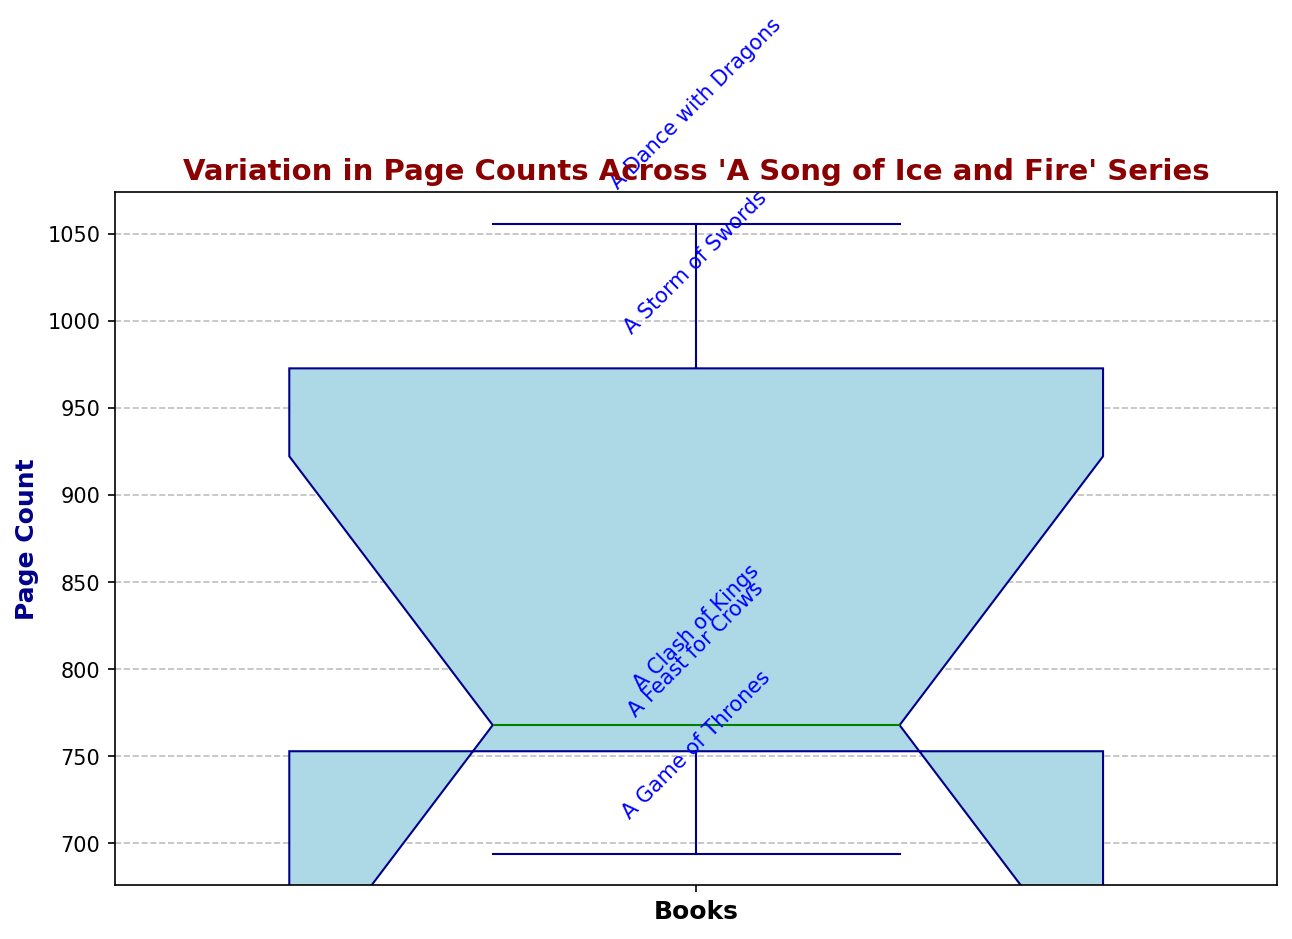Which book has the highest page count? The box plot shows individual page counts for each book in the 'A Song of Ice and Fire' series. By looking at the highest points for each book, "A Dance with Dragons" has the highest page count, indicated at the top of the plot.
Answer: A Dance with Dragons What is the median page count of the series? The median is represented by the green line in the box plot. The median page count for the series is the green line inside the box. In this case, it is around the median page count of "A Storm of Swords," which we approximate to be around 768 pages.
Answer: 768 How many books have a page count higher than 800? The plot shows individual page counts for each book. By looking at the heights above 800, we can count the books accordingly. "A Storm of Swords" and "A Dance with Dragons" both have counts above 800.
Answer: 2 What is the range of the page counts? The range is found by subtracting the smallest page count from the largest page count. The smallest page count is "A Game of Thrones" at 694 pages, and the largest is "A Dance with Dragons" at 1056 pages. The range is thus 1056 - 694.
Answer: 362 Which book has the smallest page count, and how much is it? On the box plot, the book with the smallest page count is at the bottom of the list. "A Game of Thrones" has the smallest value, indicated at 694 pages.
Answer: A Game of Thrones, 694 What is the approximate interquartile range (IQR) of the page counts? The IQR is represented by the height of the box in the box plot. It spans from the first quartile (Q1) to the third quartile (Q3). Estimating from the plot, Q1 is roughly 750 and Q3 is approximately 973. The IQR is thus 973 - 750.
Answer: 223 How do the page counts of "A Clash of Kings" and "A Feast for Crows" compare? By looking at the box plot, we can see the heights of the respective data points. "A Clash of Kings" has a higher page count (768) compared to "A Feast for Crows" (753).
Answer: A Clash of Kings > A Feast for Crows Which book's position deviates most from the median page count? The deviation from the median is the distance from the green median line. The book with the largest deviation from the median line is "A Dance with Dragons," as its individual point is farthest from the median compared to others.
Answer: A Dance with Dragons 